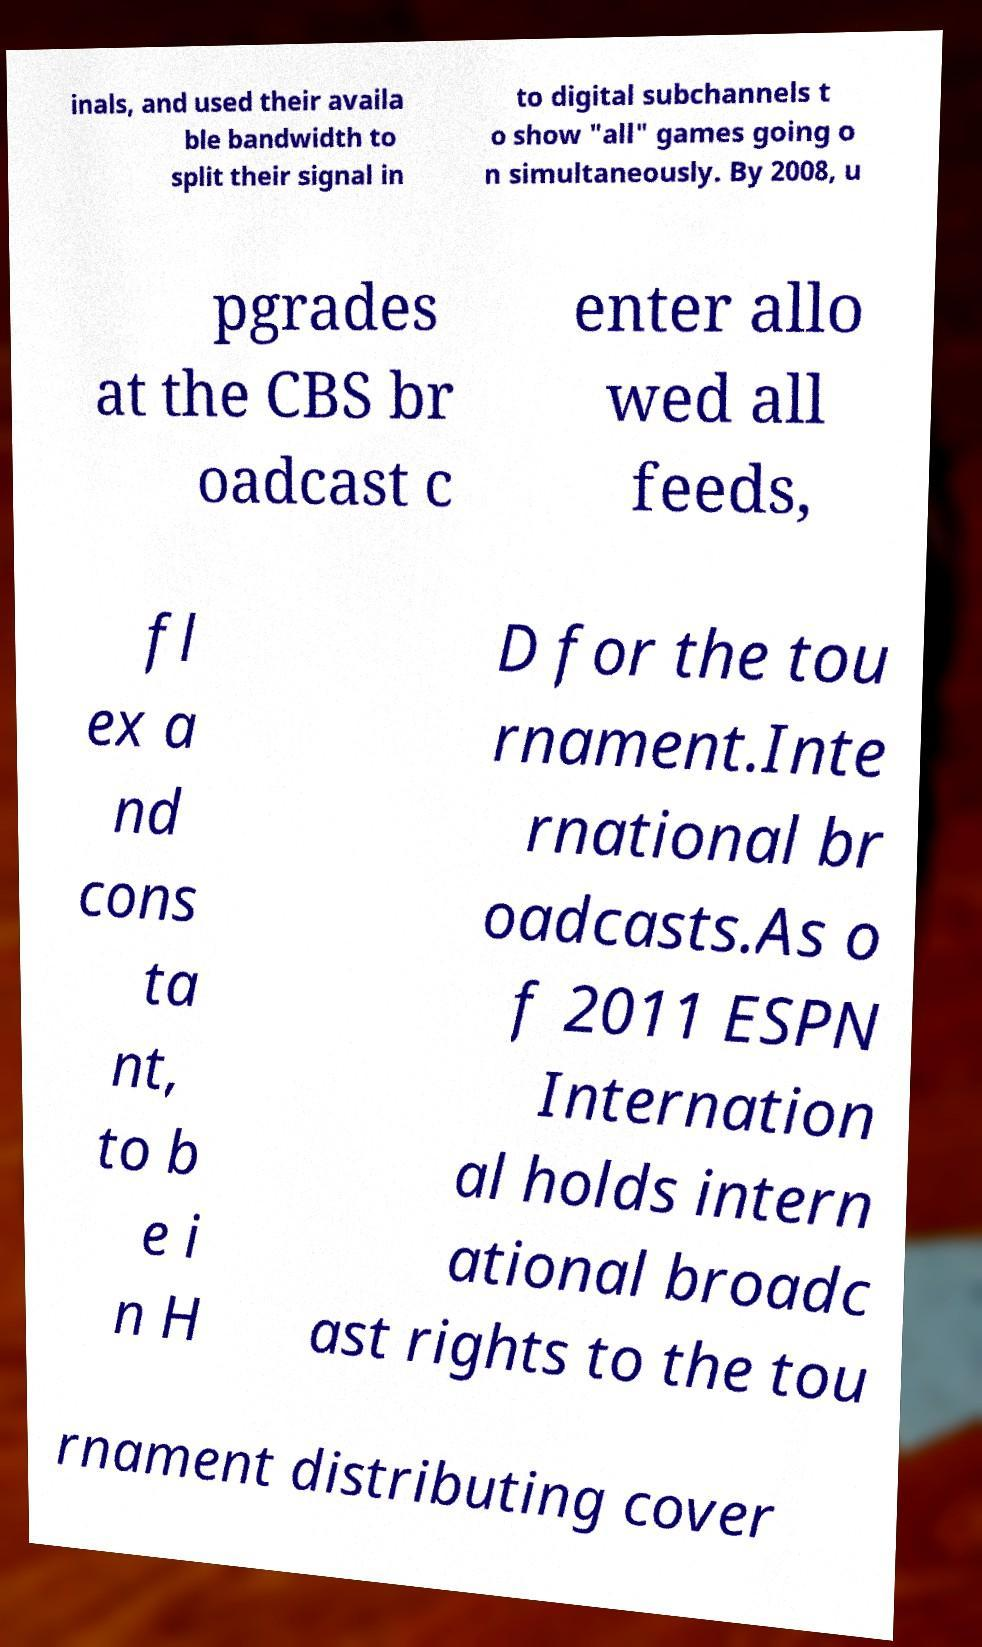Could you assist in decoding the text presented in this image and type it out clearly? inals, and used their availa ble bandwidth to split their signal in to digital subchannels t o show "all" games going o n simultaneously. By 2008, u pgrades at the CBS br oadcast c enter allo wed all feeds, fl ex a nd cons ta nt, to b e i n H D for the tou rnament.Inte rnational br oadcasts.As o f 2011 ESPN Internation al holds intern ational broadc ast rights to the tou rnament distributing cover 